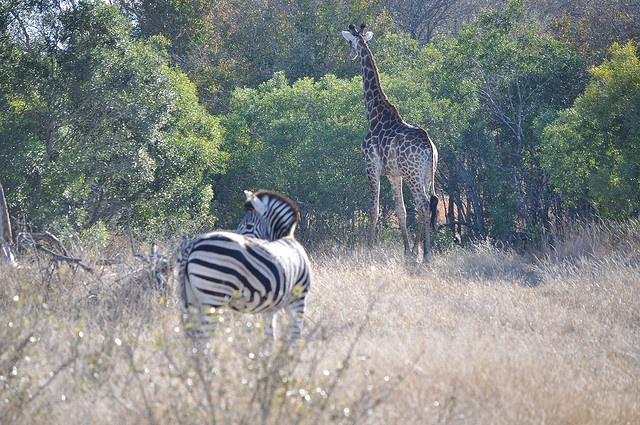Describe the objects in this image and their specific colors. I can see zebra in gray, darkgray, lightgray, and black tones and giraffe in gray, darkgray, and black tones in this image. 